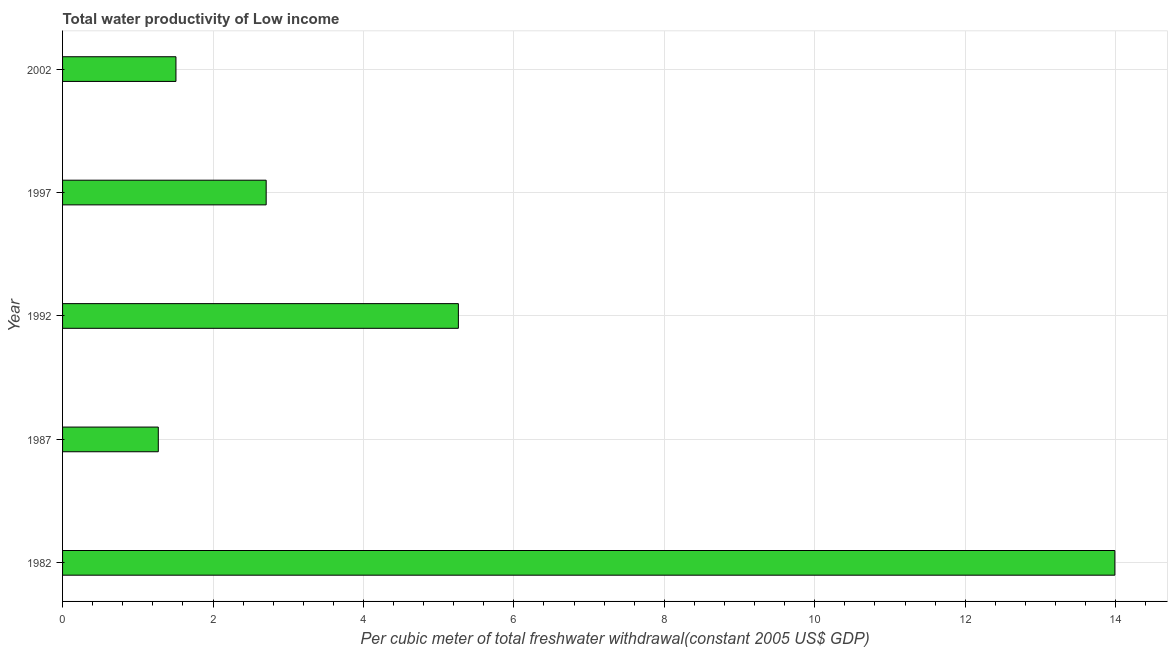Does the graph contain grids?
Offer a very short reply. Yes. What is the title of the graph?
Your answer should be compact. Total water productivity of Low income. What is the label or title of the X-axis?
Make the answer very short. Per cubic meter of total freshwater withdrawal(constant 2005 US$ GDP). What is the label or title of the Y-axis?
Offer a very short reply. Year. What is the total water productivity in 1997?
Your answer should be compact. 2.71. Across all years, what is the maximum total water productivity?
Give a very brief answer. 13.99. Across all years, what is the minimum total water productivity?
Offer a very short reply. 1.27. What is the sum of the total water productivity?
Your response must be concise. 24.74. What is the difference between the total water productivity in 1982 and 1987?
Give a very brief answer. 12.72. What is the average total water productivity per year?
Provide a short and direct response. 4.95. What is the median total water productivity?
Offer a very short reply. 2.71. What is the ratio of the total water productivity in 1997 to that in 2002?
Make the answer very short. 1.8. Is the total water productivity in 1982 less than that in 2002?
Your response must be concise. No. Is the difference between the total water productivity in 1987 and 2002 greater than the difference between any two years?
Provide a succinct answer. No. What is the difference between the highest and the second highest total water productivity?
Keep it short and to the point. 8.73. Is the sum of the total water productivity in 1992 and 1997 greater than the maximum total water productivity across all years?
Make the answer very short. No. What is the difference between the highest and the lowest total water productivity?
Provide a short and direct response. 12.72. How many years are there in the graph?
Offer a terse response. 5. What is the difference between two consecutive major ticks on the X-axis?
Give a very brief answer. 2. What is the Per cubic meter of total freshwater withdrawal(constant 2005 US$ GDP) in 1982?
Keep it short and to the point. 13.99. What is the Per cubic meter of total freshwater withdrawal(constant 2005 US$ GDP) of 1987?
Offer a terse response. 1.27. What is the Per cubic meter of total freshwater withdrawal(constant 2005 US$ GDP) in 1992?
Offer a terse response. 5.26. What is the Per cubic meter of total freshwater withdrawal(constant 2005 US$ GDP) in 1997?
Keep it short and to the point. 2.71. What is the Per cubic meter of total freshwater withdrawal(constant 2005 US$ GDP) in 2002?
Ensure brevity in your answer.  1.51. What is the difference between the Per cubic meter of total freshwater withdrawal(constant 2005 US$ GDP) in 1982 and 1987?
Ensure brevity in your answer.  12.72. What is the difference between the Per cubic meter of total freshwater withdrawal(constant 2005 US$ GDP) in 1982 and 1992?
Provide a succinct answer. 8.73. What is the difference between the Per cubic meter of total freshwater withdrawal(constant 2005 US$ GDP) in 1982 and 1997?
Provide a short and direct response. 11.28. What is the difference between the Per cubic meter of total freshwater withdrawal(constant 2005 US$ GDP) in 1982 and 2002?
Ensure brevity in your answer.  12.48. What is the difference between the Per cubic meter of total freshwater withdrawal(constant 2005 US$ GDP) in 1987 and 1992?
Ensure brevity in your answer.  -3.99. What is the difference between the Per cubic meter of total freshwater withdrawal(constant 2005 US$ GDP) in 1987 and 1997?
Ensure brevity in your answer.  -1.43. What is the difference between the Per cubic meter of total freshwater withdrawal(constant 2005 US$ GDP) in 1987 and 2002?
Your answer should be very brief. -0.23. What is the difference between the Per cubic meter of total freshwater withdrawal(constant 2005 US$ GDP) in 1992 and 1997?
Give a very brief answer. 2.56. What is the difference between the Per cubic meter of total freshwater withdrawal(constant 2005 US$ GDP) in 1992 and 2002?
Your answer should be compact. 3.75. What is the difference between the Per cubic meter of total freshwater withdrawal(constant 2005 US$ GDP) in 1997 and 2002?
Your answer should be very brief. 1.2. What is the ratio of the Per cubic meter of total freshwater withdrawal(constant 2005 US$ GDP) in 1982 to that in 1987?
Make the answer very short. 10.99. What is the ratio of the Per cubic meter of total freshwater withdrawal(constant 2005 US$ GDP) in 1982 to that in 1992?
Your answer should be compact. 2.66. What is the ratio of the Per cubic meter of total freshwater withdrawal(constant 2005 US$ GDP) in 1982 to that in 1997?
Give a very brief answer. 5.17. What is the ratio of the Per cubic meter of total freshwater withdrawal(constant 2005 US$ GDP) in 1982 to that in 2002?
Keep it short and to the point. 9.28. What is the ratio of the Per cubic meter of total freshwater withdrawal(constant 2005 US$ GDP) in 1987 to that in 1992?
Offer a very short reply. 0.24. What is the ratio of the Per cubic meter of total freshwater withdrawal(constant 2005 US$ GDP) in 1987 to that in 1997?
Ensure brevity in your answer.  0.47. What is the ratio of the Per cubic meter of total freshwater withdrawal(constant 2005 US$ GDP) in 1987 to that in 2002?
Provide a succinct answer. 0.84. What is the ratio of the Per cubic meter of total freshwater withdrawal(constant 2005 US$ GDP) in 1992 to that in 1997?
Offer a terse response. 1.94. What is the ratio of the Per cubic meter of total freshwater withdrawal(constant 2005 US$ GDP) in 1992 to that in 2002?
Ensure brevity in your answer.  3.49. What is the ratio of the Per cubic meter of total freshwater withdrawal(constant 2005 US$ GDP) in 1997 to that in 2002?
Offer a very short reply. 1.8. 